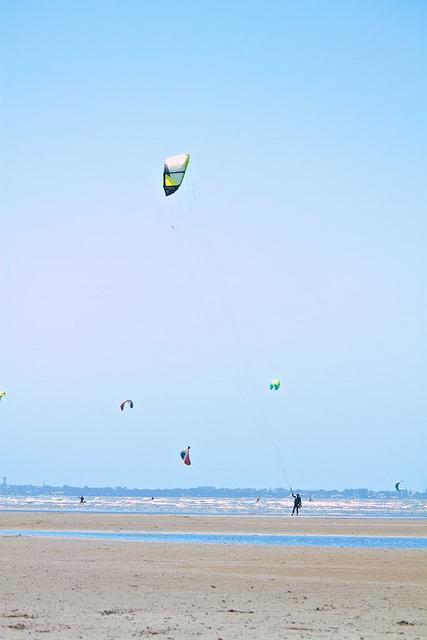How many kites are flying in the air?
Give a very brief answer. 4. How many giraffes are there?
Give a very brief answer. 0. 